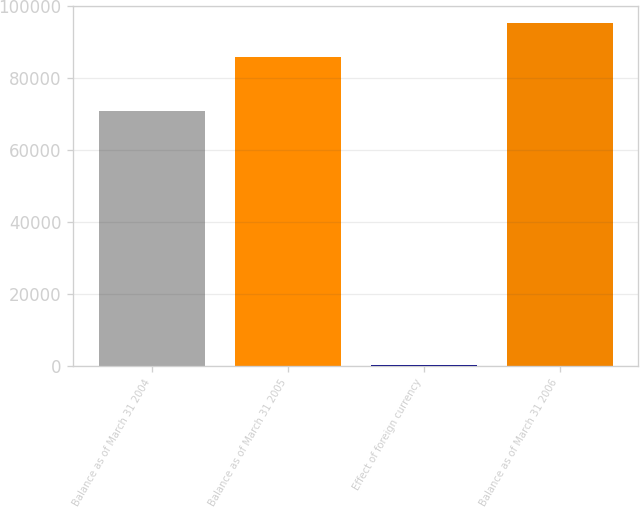<chart> <loc_0><loc_0><loc_500><loc_500><bar_chart><fcel>Balance as of March 31 2004<fcel>Balance as of March 31 2005<fcel>Effect of foreign currency<fcel>Balance as of March 31 2006<nl><fcel>70898<fcel>85899<fcel>203<fcel>95388.1<nl></chart> 